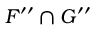<formula> <loc_0><loc_0><loc_500><loc_500>F ^ { \prime \prime } \cap G ^ { \prime \prime }</formula> 